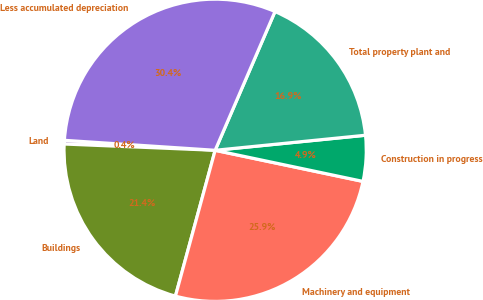<chart> <loc_0><loc_0><loc_500><loc_500><pie_chart><fcel>Land<fcel>Buildings<fcel>Machinery and equipment<fcel>Construction in progress<fcel>Total property plant and<fcel>Less accumulated depreciation<nl><fcel>0.39%<fcel>21.43%<fcel>25.93%<fcel>4.89%<fcel>16.93%<fcel>30.43%<nl></chart> 